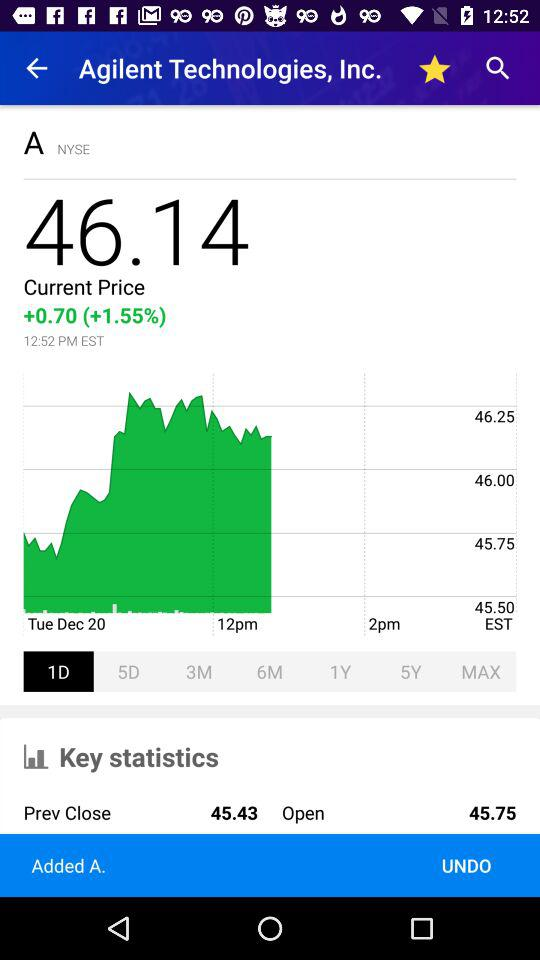What is the current price of the stock?
Answer the question using a single word or phrase. 46.14 